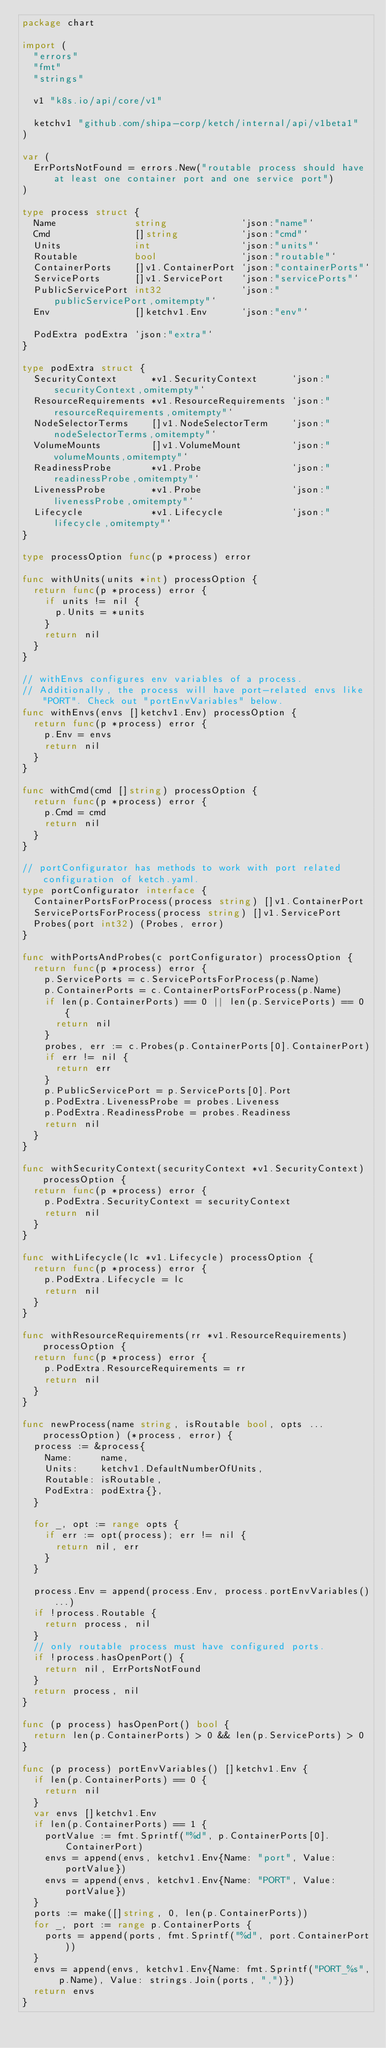<code> <loc_0><loc_0><loc_500><loc_500><_Go_>package chart

import (
	"errors"
	"fmt"
	"strings"

	v1 "k8s.io/api/core/v1"

	ketchv1 "github.com/shipa-corp/ketch/internal/api/v1beta1"
)

var (
	ErrPortsNotFound = errors.New("routable process should have at least one container port and one service port")
)

type process struct {
	Name              string             `json:"name"`
	Cmd               []string           `json:"cmd"`
	Units             int                `json:"units"`
	Routable          bool               `json:"routable"`
	ContainerPorts    []v1.ContainerPort `json:"containerPorts"`
	ServicePorts      []v1.ServicePort   `json:"servicePorts"`
	PublicServicePort int32              `json:"publicServicePort,omitempty"`
	Env               []ketchv1.Env      `json:"env"`

	PodExtra podExtra `json:"extra"`
}

type podExtra struct {
	SecurityContext      *v1.SecurityContext      `json:"securityContext,omitempty"`
	ResourceRequirements *v1.ResourceRequirements `json:"resourceRequirements,omitempty"`
	NodeSelectorTerms    []v1.NodeSelectorTerm    `json:"nodeSelectorTerms,omitempty"`
	VolumeMounts         []v1.VolumeMount         `json:"volumeMounts,omitempty"`
	ReadinessProbe       *v1.Probe                `json:"readinessProbe,omitempty"`
	LivenessProbe        *v1.Probe                `json:"livenessProbe,omitempty"`
	Lifecycle            *v1.Lifecycle            `json:"lifecycle,omitempty"`
}

type processOption func(p *process) error

func withUnits(units *int) processOption {
	return func(p *process) error {
		if units != nil {
			p.Units = *units
		}
		return nil
	}
}

// withEnvs configures env variables of a process.
// Additionally, the process will have port-related envs like "PORT". Check out "portEnvVariables" below.
func withEnvs(envs []ketchv1.Env) processOption {
	return func(p *process) error {
		p.Env = envs
		return nil
	}
}

func withCmd(cmd []string) processOption {
	return func(p *process) error {
		p.Cmd = cmd
		return nil
	}
}

// portConfigurator has methods to work with port related configuration of ketch.yaml.
type portConfigurator interface {
	ContainerPortsForProcess(process string) []v1.ContainerPort
	ServicePortsForProcess(process string) []v1.ServicePort
	Probes(port int32) (Probes, error)
}

func withPortsAndProbes(c portConfigurator) processOption {
	return func(p *process) error {
		p.ServicePorts = c.ServicePortsForProcess(p.Name)
		p.ContainerPorts = c.ContainerPortsForProcess(p.Name)
		if len(p.ContainerPorts) == 0 || len(p.ServicePorts) == 0 {
			return nil
		}
		probes, err := c.Probes(p.ContainerPorts[0].ContainerPort)
		if err != nil {
			return err
		}
		p.PublicServicePort = p.ServicePorts[0].Port
		p.PodExtra.LivenessProbe = probes.Liveness
		p.PodExtra.ReadinessProbe = probes.Readiness
		return nil
	}
}

func withSecurityContext(securityContext *v1.SecurityContext) processOption {
	return func(p *process) error {
		p.PodExtra.SecurityContext = securityContext
		return nil
	}
}

func withLifecycle(lc *v1.Lifecycle) processOption {
	return func(p *process) error {
		p.PodExtra.Lifecycle = lc
		return nil
	}
}

func withResourceRequirements(rr *v1.ResourceRequirements) processOption {
	return func(p *process) error {
		p.PodExtra.ResourceRequirements = rr
		return nil
	}
}

func newProcess(name string, isRoutable bool, opts ...processOption) (*process, error) {
	process := &process{
		Name:     name,
		Units:    ketchv1.DefaultNumberOfUnits,
		Routable: isRoutable,
		PodExtra: podExtra{},
	}

	for _, opt := range opts {
		if err := opt(process); err != nil {
			return nil, err
		}
	}

	process.Env = append(process.Env, process.portEnvVariables()...)
	if !process.Routable {
		return process, nil
	}
	// only routable process must have configured ports.
	if !process.hasOpenPort() {
		return nil, ErrPortsNotFound
	}
	return process, nil
}

func (p process) hasOpenPort() bool {
	return len(p.ContainerPorts) > 0 && len(p.ServicePorts) > 0
}

func (p process) portEnvVariables() []ketchv1.Env {
	if len(p.ContainerPorts) == 0 {
		return nil
	}
	var envs []ketchv1.Env
	if len(p.ContainerPorts) == 1 {
		portValue := fmt.Sprintf("%d", p.ContainerPorts[0].ContainerPort)
		envs = append(envs, ketchv1.Env{Name: "port", Value: portValue})
		envs = append(envs, ketchv1.Env{Name: "PORT", Value: portValue})
	}
	ports := make([]string, 0, len(p.ContainerPorts))
	for _, port := range p.ContainerPorts {
		ports = append(ports, fmt.Sprintf("%d", port.ContainerPort))
	}
	envs = append(envs, ketchv1.Env{Name: fmt.Sprintf("PORT_%s", p.Name), Value: strings.Join(ports, ",")})
	return envs
}
</code> 